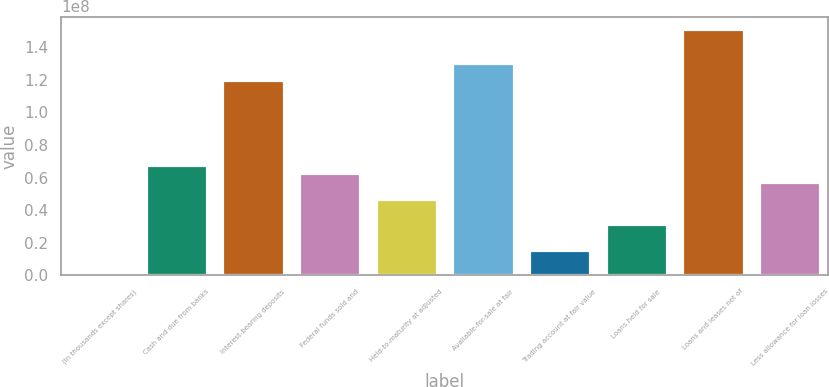<chart> <loc_0><loc_0><loc_500><loc_500><bar_chart><fcel>(In thousands except shares)<fcel>Cash and due from banks<fcel>Interest-bearing deposits<fcel>Federal funds sold and<fcel>Held-to-maturity at adjusted<fcel>Available-for-sale at fair<fcel>Trading account at fair value<fcel>Loans held for sale<fcel>Loans and leases net of<fcel>Less allowance for loan losses<nl><fcel>2015<fcel>6.781e+07<fcel>1.1997e+08<fcel>6.2594e+07<fcel>4.6946e+07<fcel>1.30402e+08<fcel>1.565e+07<fcel>3.1298e+07<fcel>1.51266e+08<fcel>5.7378e+07<nl></chart> 